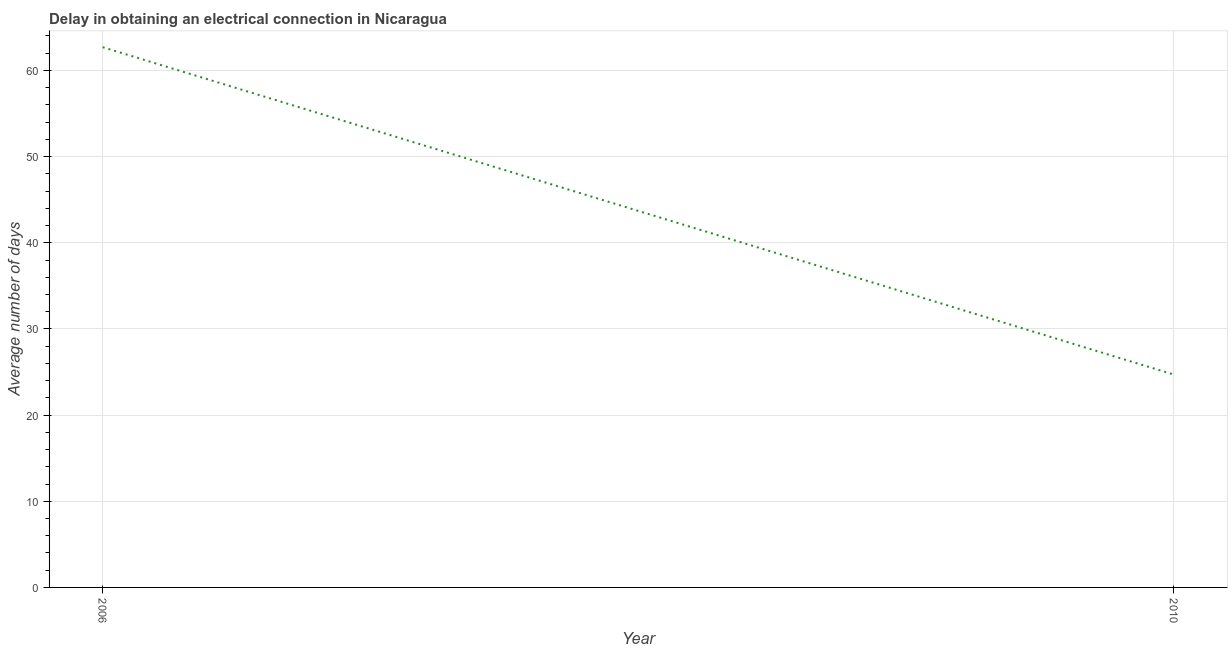What is the dalay in electrical connection in 2006?
Offer a very short reply. 62.7. Across all years, what is the maximum dalay in electrical connection?
Offer a terse response. 62.7. Across all years, what is the minimum dalay in electrical connection?
Make the answer very short. 24.7. In which year was the dalay in electrical connection maximum?
Ensure brevity in your answer.  2006. In which year was the dalay in electrical connection minimum?
Ensure brevity in your answer.  2010. What is the sum of the dalay in electrical connection?
Keep it short and to the point. 87.4. What is the difference between the dalay in electrical connection in 2006 and 2010?
Give a very brief answer. 38. What is the average dalay in electrical connection per year?
Ensure brevity in your answer.  43.7. What is the median dalay in electrical connection?
Keep it short and to the point. 43.7. In how many years, is the dalay in electrical connection greater than 34 days?
Your answer should be very brief. 1. Do a majority of the years between 2010 and 2006 (inclusive) have dalay in electrical connection greater than 6 days?
Provide a succinct answer. No. What is the ratio of the dalay in electrical connection in 2006 to that in 2010?
Make the answer very short. 2.54. Does the dalay in electrical connection monotonically increase over the years?
Offer a very short reply. No. How many lines are there?
Your answer should be compact. 1. What is the difference between two consecutive major ticks on the Y-axis?
Provide a succinct answer. 10. Does the graph contain any zero values?
Keep it short and to the point. No. Does the graph contain grids?
Your response must be concise. Yes. What is the title of the graph?
Offer a very short reply. Delay in obtaining an electrical connection in Nicaragua. What is the label or title of the X-axis?
Your answer should be compact. Year. What is the label or title of the Y-axis?
Make the answer very short. Average number of days. What is the Average number of days in 2006?
Keep it short and to the point. 62.7. What is the Average number of days in 2010?
Your response must be concise. 24.7. What is the ratio of the Average number of days in 2006 to that in 2010?
Keep it short and to the point. 2.54. 